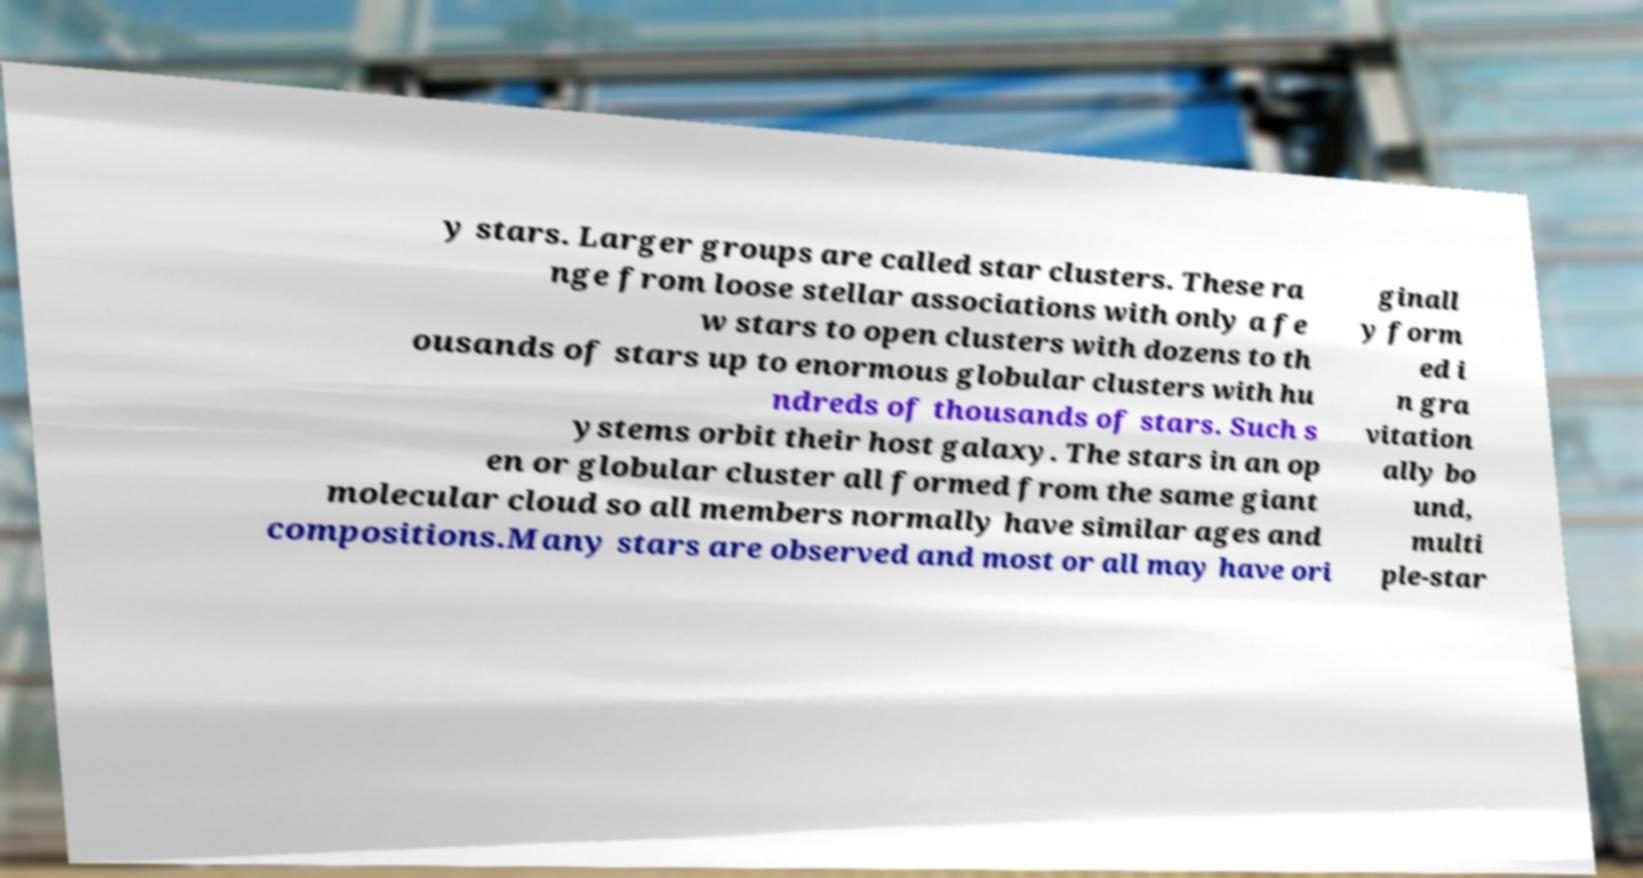Please read and relay the text visible in this image. What does it say? y stars. Larger groups are called star clusters. These ra nge from loose stellar associations with only a fe w stars to open clusters with dozens to th ousands of stars up to enormous globular clusters with hu ndreds of thousands of stars. Such s ystems orbit their host galaxy. The stars in an op en or globular cluster all formed from the same giant molecular cloud so all members normally have similar ages and compositions.Many stars are observed and most or all may have ori ginall y form ed i n gra vitation ally bo und, multi ple-star 